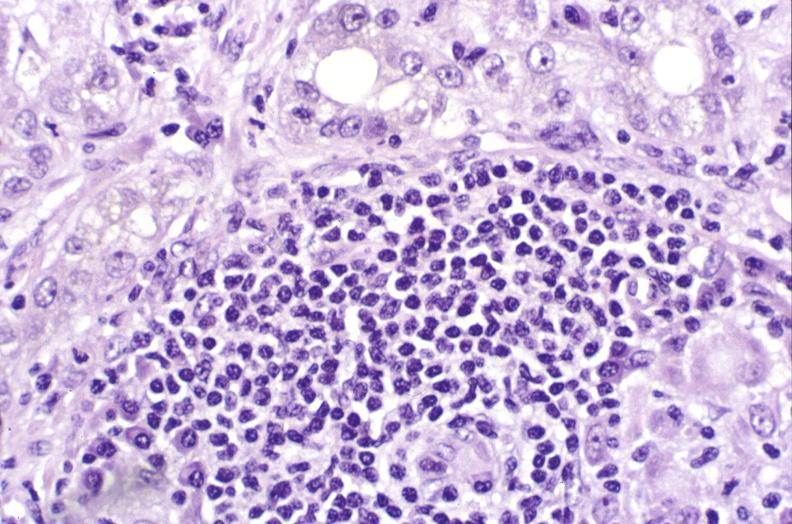s hepatobiliary present?
Answer the question using a single word or phrase. Yes 